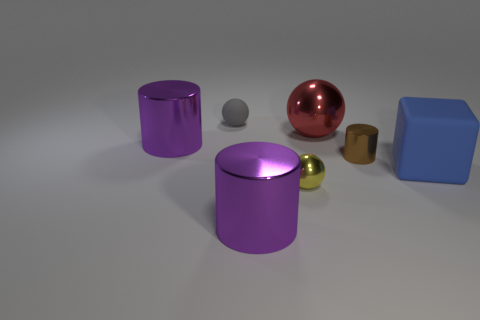Add 3 big rubber blocks. How many objects exist? 10 Subtract all cubes. How many objects are left? 6 Add 2 big brown rubber objects. How many big brown rubber objects exist? 2 Subtract 0 cyan blocks. How many objects are left? 7 Subtract all brown metallic objects. Subtract all tiny yellow metallic things. How many objects are left? 5 Add 2 big cylinders. How many big cylinders are left? 4 